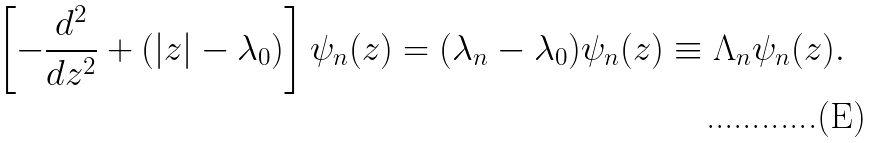<formula> <loc_0><loc_0><loc_500><loc_500>\left [ - \frac { d ^ { 2 } } { d z ^ { 2 } } + ( | z | - \lambda _ { 0 } ) \right ] \psi _ { n } ( z ) = ( \lambda _ { n } - \lambda _ { 0 } ) \psi _ { n } ( z ) \equiv \Lambda _ { n } \psi _ { n } ( z ) .</formula> 